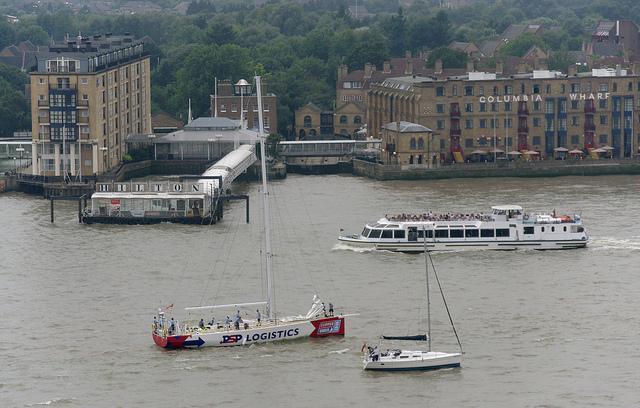In what country is this river in?
Answer the question by selecting the correct answer among the 4 following choices and explain your choice with a short sentence. The answer should be formatted with the following format: `Answer: choice
Rationale: rationale.`
Options: Italy, britain, france, spain. Answer: britain.
Rationale: There are english words on the buildings 